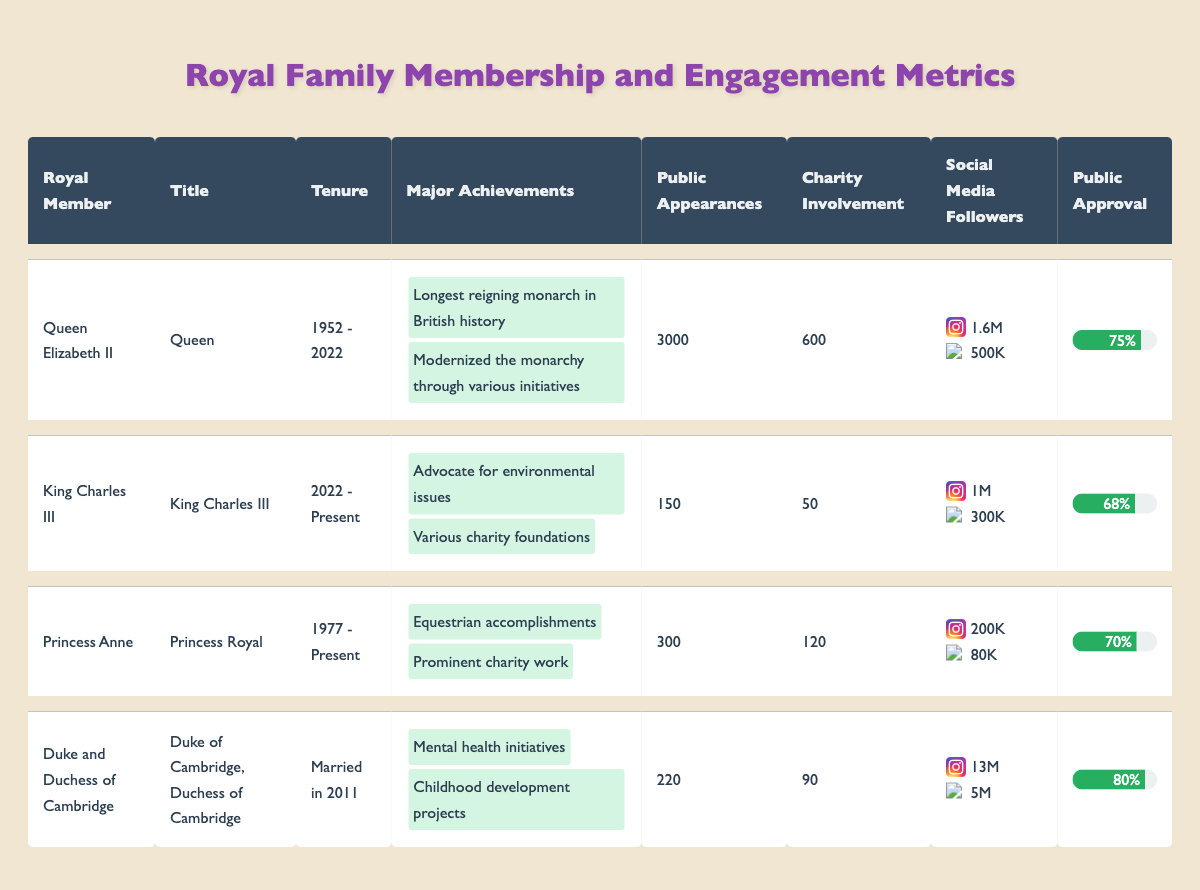What is the total number of public appearances made by the Duke and Duchess of Cambridge? The Duke and Duchess of Cambridge made 220 public appearances according to the table.
Answer: 220 What is Queen Elizabeth II's approval rating? The approval rating for Queen Elizabeth II is listed as 75% in the table.
Answer: 75% Who has the highest social media following on Instagram? By checking the Instagram followers, the Duke and Duchess of Cambridge have 13 million followers, which is the highest among all royal members.
Answer: Duke and Duchess of Cambridge Is Princess Anne's charity involvement greater than King Charles III's? Princess Anne is credited with 120 charity involvements while King Charles III has 50. Since 120 is greater than 50, the answer is yes.
Answer: Yes What is the average number of public appearances made by the royal members listed in the table? The total public appearances are: 3000 (Queen Elizabeth II) + 150 (King Charles III) + 300 (Princess Anne) + 220 (Duke and Duchess of Cambridge) = 3670. There are 4 royal members in total, so the average is 3670 / 4 = 917.5.
Answer: 917.5 Did any royal member have a negative perception of less than 10%? Queen Elizabeth II has a negative perception of 5%, which is less than 10%. Therefore, the answer is yes.
Answer: Yes What is the combined number of charity involvements of all royal members? Adding up: 600 (Queen Elizabeth II) + 50 (King Charles III) + 120 (Princess Anne) + 90 (Duke and Duchess of Cambridge) = 860, therefore the combined number is 860.
Answer: 860 Which royal member has the least public appearances? King Charles III has recorded 150 public appearances, which is the least among the members listed.
Answer: King Charles III How many more charity involvements does Princess Anne have compared to King Charles III? Princess Anne has 120 charity involvements and King Charles III has 50; the difference is 120 - 50 = 70. Therefore, Princess Anne has 70 more charity involvements.
Answer: 70 